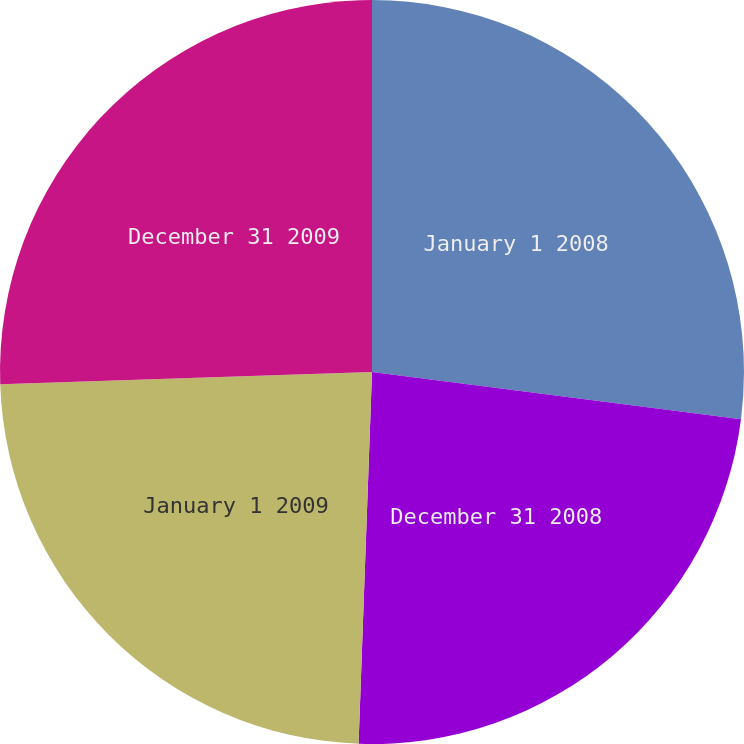<chart> <loc_0><loc_0><loc_500><loc_500><pie_chart><fcel>January 1 2008<fcel>December 31 2008<fcel>January 1 2009<fcel>December 31 2009<nl><fcel>27.03%<fcel>23.55%<fcel>23.9%<fcel>25.53%<nl></chart> 